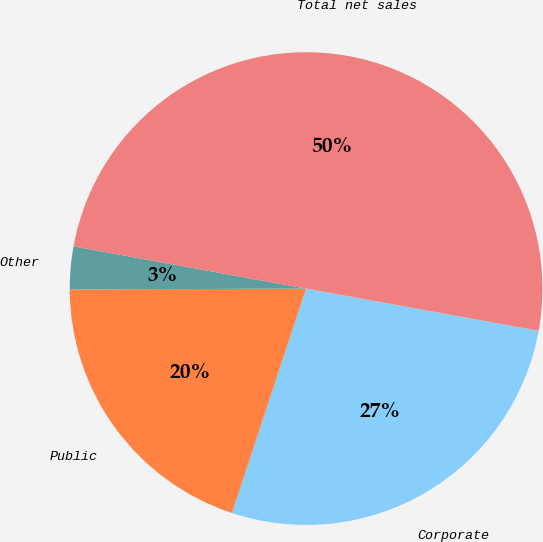Convert chart to OTSL. <chart><loc_0><loc_0><loc_500><loc_500><pie_chart><fcel>Corporate<fcel>Public<fcel>Other<fcel>Total net sales<nl><fcel>27.22%<fcel>19.86%<fcel>2.92%<fcel>50.0%<nl></chart> 